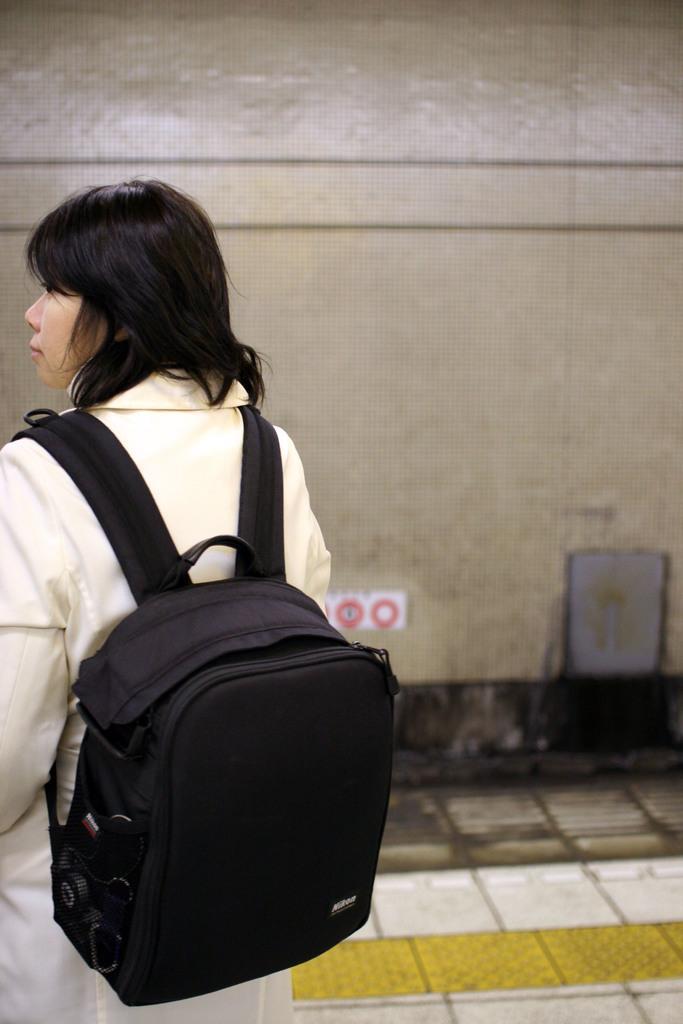In one or two sentences, can you explain what this image depicts? A woman is carrying a bag and standing behind her there is a wall. 